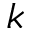Convert formula to latex. <formula><loc_0><loc_0><loc_500><loc_500>k</formula> 